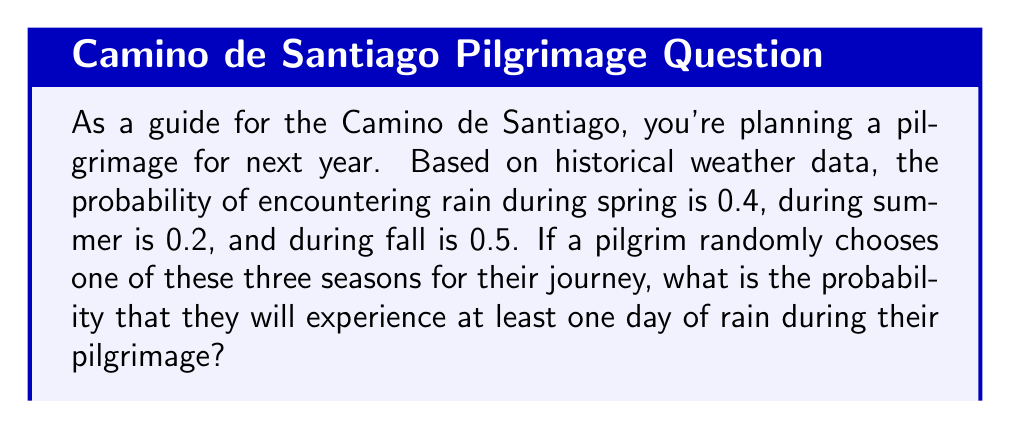Solve this math problem. Let's approach this step-by-step:

1) First, let's define our events:
   R = experiencing at least one day of rain
   S = Spring, M = Summer, F = Fall

2) We're given the following probabilities:
   $P(R|S) = 0.4$
   $P(R|M) = 0.2$
   $P(R|F) = 0.5$

3) Since the pilgrim randomly chooses one of the three seasons, the probability of each season is equal:
   $P(S) = P(M) = P(F) = \frac{1}{3}$

4) To find the probability of experiencing rain, we can use the law of total probability:
   $P(R) = P(R|S)P(S) + P(R|M)P(M) + P(R|F)P(F)$

5) Substituting the values:
   $P(R) = 0.4 \cdot \frac{1}{3} + 0.2 \cdot \frac{1}{3} + 0.5 \cdot \frac{1}{3}$

6) Simplifying:
   $P(R) = \frac{0.4 + 0.2 + 0.5}{3} = \frac{1.1}{3} \approx 0.3667$

Therefore, the probability of experiencing at least one day of rain during the pilgrimage is approximately 0.3667 or about 36.67%.
Answer: $\frac{1.1}{3}$ or approximately 0.3667 (36.67%) 